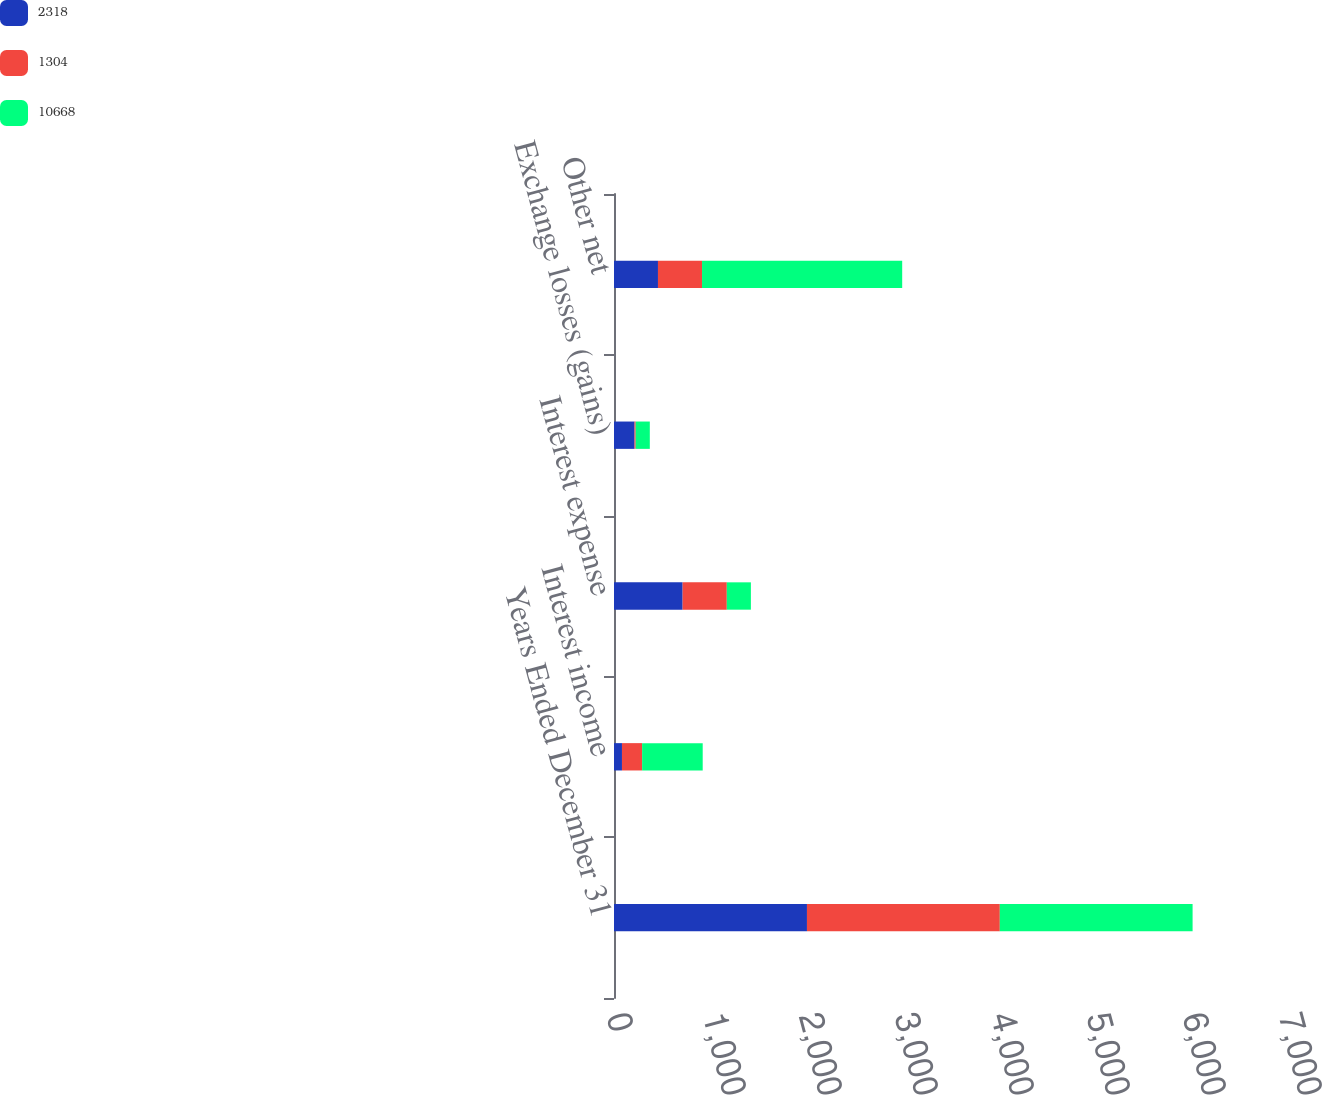Convert chart. <chart><loc_0><loc_0><loc_500><loc_500><stacked_bar_chart><ecel><fcel>Years Ended December 31<fcel>Interest income<fcel>Interest expense<fcel>Exchange losses (gains)<fcel>Other net<nl><fcel>2318<fcel>2010<fcel>83<fcel>715<fcel>214<fcel>458<nl><fcel>1304<fcel>2009<fcel>210<fcel>460<fcel>12<fcel>459<nl><fcel>10668<fcel>2008<fcel>631<fcel>251<fcel>147<fcel>2085<nl></chart> 